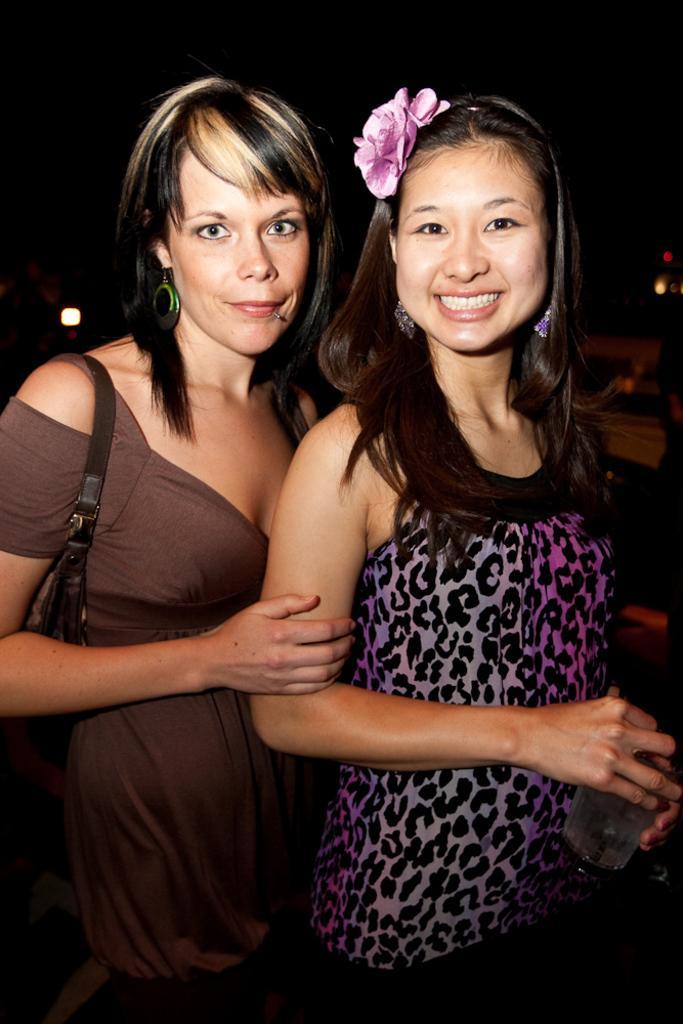How would you summarize this image in a sentence or two? In this image there are two women standing. The woman to the right is holding a glass in her hand. The woman to the left is wearing a handbag. The background is dark. 